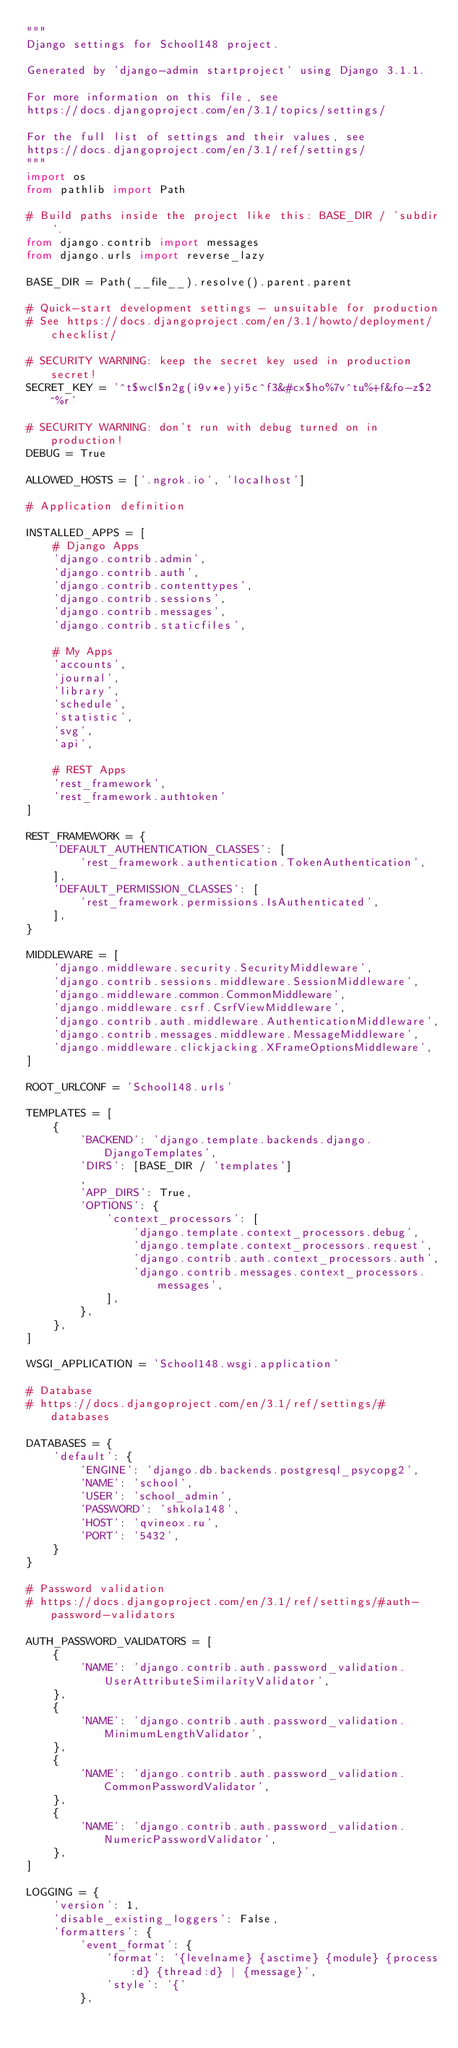Convert code to text. <code><loc_0><loc_0><loc_500><loc_500><_Python_>"""
Django settings for School148 project.

Generated by 'django-admin startproject' using Django 3.1.1.

For more information on this file, see
https://docs.djangoproject.com/en/3.1/topics/settings/

For the full list of settings and their values, see
https://docs.djangoproject.com/en/3.1/ref/settings/
"""
import os
from pathlib import Path

# Build paths inside the project like this: BASE_DIR / 'subdir'.
from django.contrib import messages
from django.urls import reverse_lazy

BASE_DIR = Path(__file__).resolve().parent.parent

# Quick-start development settings - unsuitable for production
# See https://docs.djangoproject.com/en/3.1/howto/deployment/checklist/

# SECURITY WARNING: keep the secret key used in production secret!
SECRET_KEY = '^t$wcl$n2g(i9v*e)yi5c^f3&#cx$ho%7v^tu%+f&fo-z$2^%r'

# SECURITY WARNING: don't run with debug turned on in production!
DEBUG = True

ALLOWED_HOSTS = ['.ngrok.io', 'localhost']

# Application definition

INSTALLED_APPS = [
    # Django Apps
    'django.contrib.admin',
    'django.contrib.auth',
    'django.contrib.contenttypes',
    'django.contrib.sessions',
    'django.contrib.messages',
    'django.contrib.staticfiles',

    # My Apps
    'accounts',
    'journal',
    'library',
    'schedule',
    'statistic',
    'svg',
    'api',

    # REST Apps
    'rest_framework',
    'rest_framework.authtoken'
]

REST_FRAMEWORK = {
    'DEFAULT_AUTHENTICATION_CLASSES': [
        'rest_framework.authentication.TokenAuthentication',
    ],
    'DEFAULT_PERMISSION_CLASSES': [
        'rest_framework.permissions.IsAuthenticated',
    ],
}

MIDDLEWARE = [
    'django.middleware.security.SecurityMiddleware',
    'django.contrib.sessions.middleware.SessionMiddleware',
    'django.middleware.common.CommonMiddleware',
    'django.middleware.csrf.CsrfViewMiddleware',
    'django.contrib.auth.middleware.AuthenticationMiddleware',
    'django.contrib.messages.middleware.MessageMiddleware',
    'django.middleware.clickjacking.XFrameOptionsMiddleware',
]

ROOT_URLCONF = 'School148.urls'

TEMPLATES = [
    {
        'BACKEND': 'django.template.backends.django.DjangoTemplates',
        'DIRS': [BASE_DIR / 'templates']
        ,
        'APP_DIRS': True,
        'OPTIONS': {
            'context_processors': [
                'django.template.context_processors.debug',
                'django.template.context_processors.request',
                'django.contrib.auth.context_processors.auth',
                'django.contrib.messages.context_processors.messages',
            ],
        },
    },
]

WSGI_APPLICATION = 'School148.wsgi.application'

# Database
# https://docs.djangoproject.com/en/3.1/ref/settings/#databases

DATABASES = {
    'default': {
        'ENGINE': 'django.db.backends.postgresql_psycopg2',
        'NAME': 'school',
        'USER': 'school_admin',
        'PASSWORD': 'shkola148',
        'HOST': 'qvineox.ru',
        'PORT': '5432',
    }
}

# Password validation
# https://docs.djangoproject.com/en/3.1/ref/settings/#auth-password-validators

AUTH_PASSWORD_VALIDATORS = [
    {
        'NAME': 'django.contrib.auth.password_validation.UserAttributeSimilarityValidator',
    },
    {
        'NAME': 'django.contrib.auth.password_validation.MinimumLengthValidator',
    },
    {
        'NAME': 'django.contrib.auth.password_validation.CommonPasswordValidator',
    },
    {
        'NAME': 'django.contrib.auth.password_validation.NumericPasswordValidator',
    },
]

LOGGING = {
    'version': 1,
    'disable_existing_loggers': False,
    'formatters': {
        'event_format': {
            'format': '{levelname} {asctime} {module} {process:d} {thread:d} | {message}',
            'style': '{'
        },</code> 